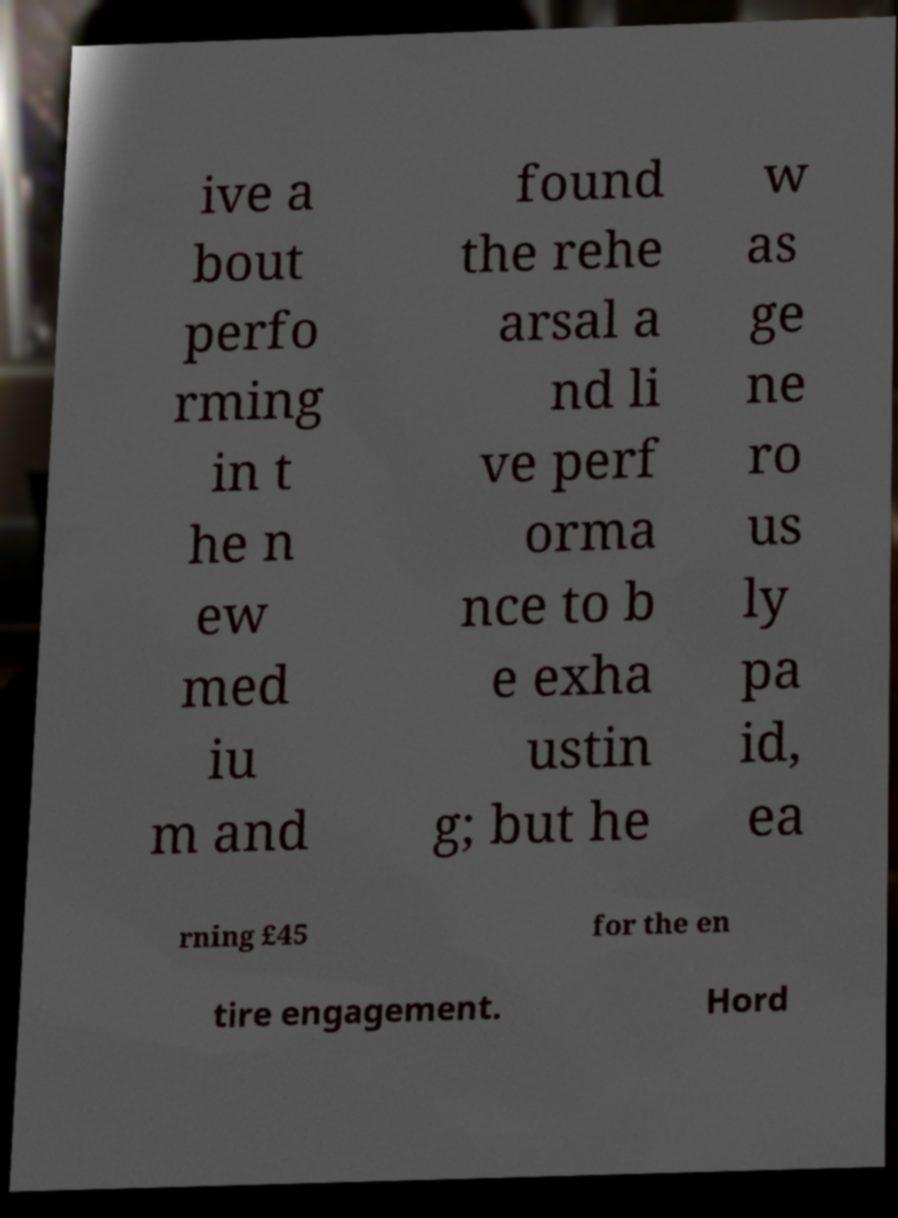I need the written content from this picture converted into text. Can you do that? ive a bout perfo rming in t he n ew med iu m and found the rehe arsal a nd li ve perf orma nce to b e exha ustin g; but he w as ge ne ro us ly pa id, ea rning £45 for the en tire engagement. Hord 